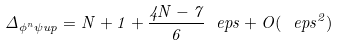Convert formula to latex. <formula><loc_0><loc_0><loc_500><loc_500>\Delta _ { \phi ^ { n } \psi u p } = N + 1 + \frac { 4 N - 7 } 6 \ e p s + O ( \ e p s ^ { 2 } )</formula> 